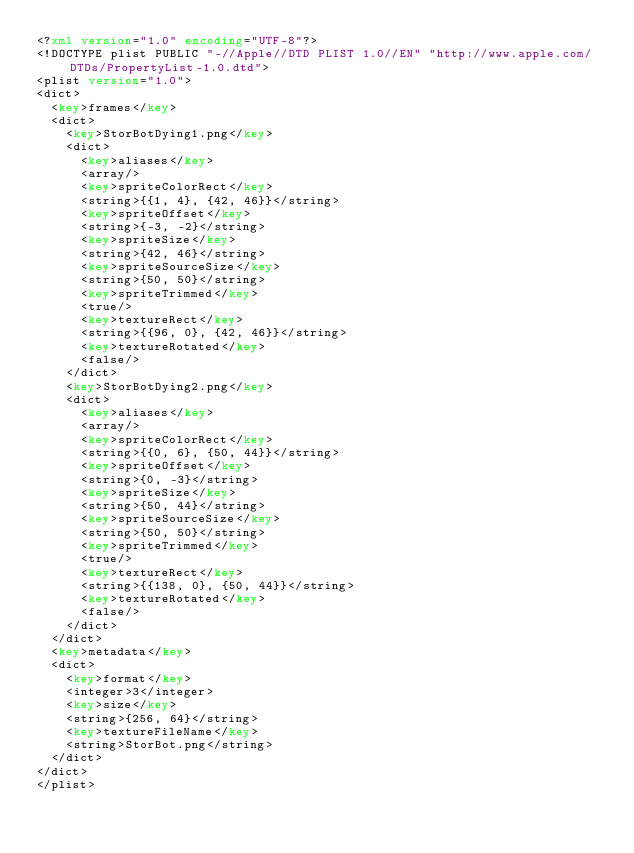<code> <loc_0><loc_0><loc_500><loc_500><_XML_><?xml version="1.0" encoding="UTF-8"?>
<!DOCTYPE plist PUBLIC "-//Apple//DTD PLIST 1.0//EN" "http://www.apple.com/DTDs/PropertyList-1.0.dtd">
<plist version="1.0">
<dict>
	<key>frames</key>
	<dict>
		<key>StorBotDying1.png</key>
		<dict>
			<key>aliases</key>
			<array/>
			<key>spriteColorRect</key>
			<string>{{1, 4}, {42, 46}}</string>
			<key>spriteOffset</key>
			<string>{-3, -2}</string>
			<key>spriteSize</key>
			<string>{42, 46}</string>
			<key>spriteSourceSize</key>
			<string>{50, 50}</string>
			<key>spriteTrimmed</key>
			<true/>
			<key>textureRect</key>
			<string>{{96, 0}, {42, 46}}</string>
			<key>textureRotated</key>
			<false/>
		</dict>
		<key>StorBotDying2.png</key>
		<dict>
			<key>aliases</key>
			<array/>
			<key>spriteColorRect</key>
			<string>{{0, 6}, {50, 44}}</string>
			<key>spriteOffset</key>
			<string>{0, -3}</string>
			<key>spriteSize</key>
			<string>{50, 44}</string>
			<key>spriteSourceSize</key>
			<string>{50, 50}</string>
			<key>spriteTrimmed</key>
			<true/>
			<key>textureRect</key>
			<string>{{138, 0}, {50, 44}}</string>
			<key>textureRotated</key>
			<false/>
		</dict>
	</dict>
	<key>metadata</key>
	<dict>
		<key>format</key>
		<integer>3</integer>
		<key>size</key>
		<string>{256, 64}</string>
		<key>textureFileName</key>
		<string>StorBot.png</string>
	</dict>
</dict>
</plist>
</code> 